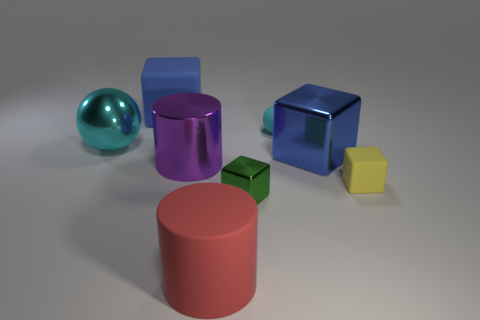How does the lighting in the scene affect the appearance of the objects? The lighting in this scene creates soft shadows and highlights on the objects, which enhances their three-dimensionality and the perception of their textures. The direction of the light also seems to be coming from the upper left, which highlights the shape of the objects and gives depth to the scene. 